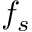<formula> <loc_0><loc_0><loc_500><loc_500>f _ { s }</formula> 